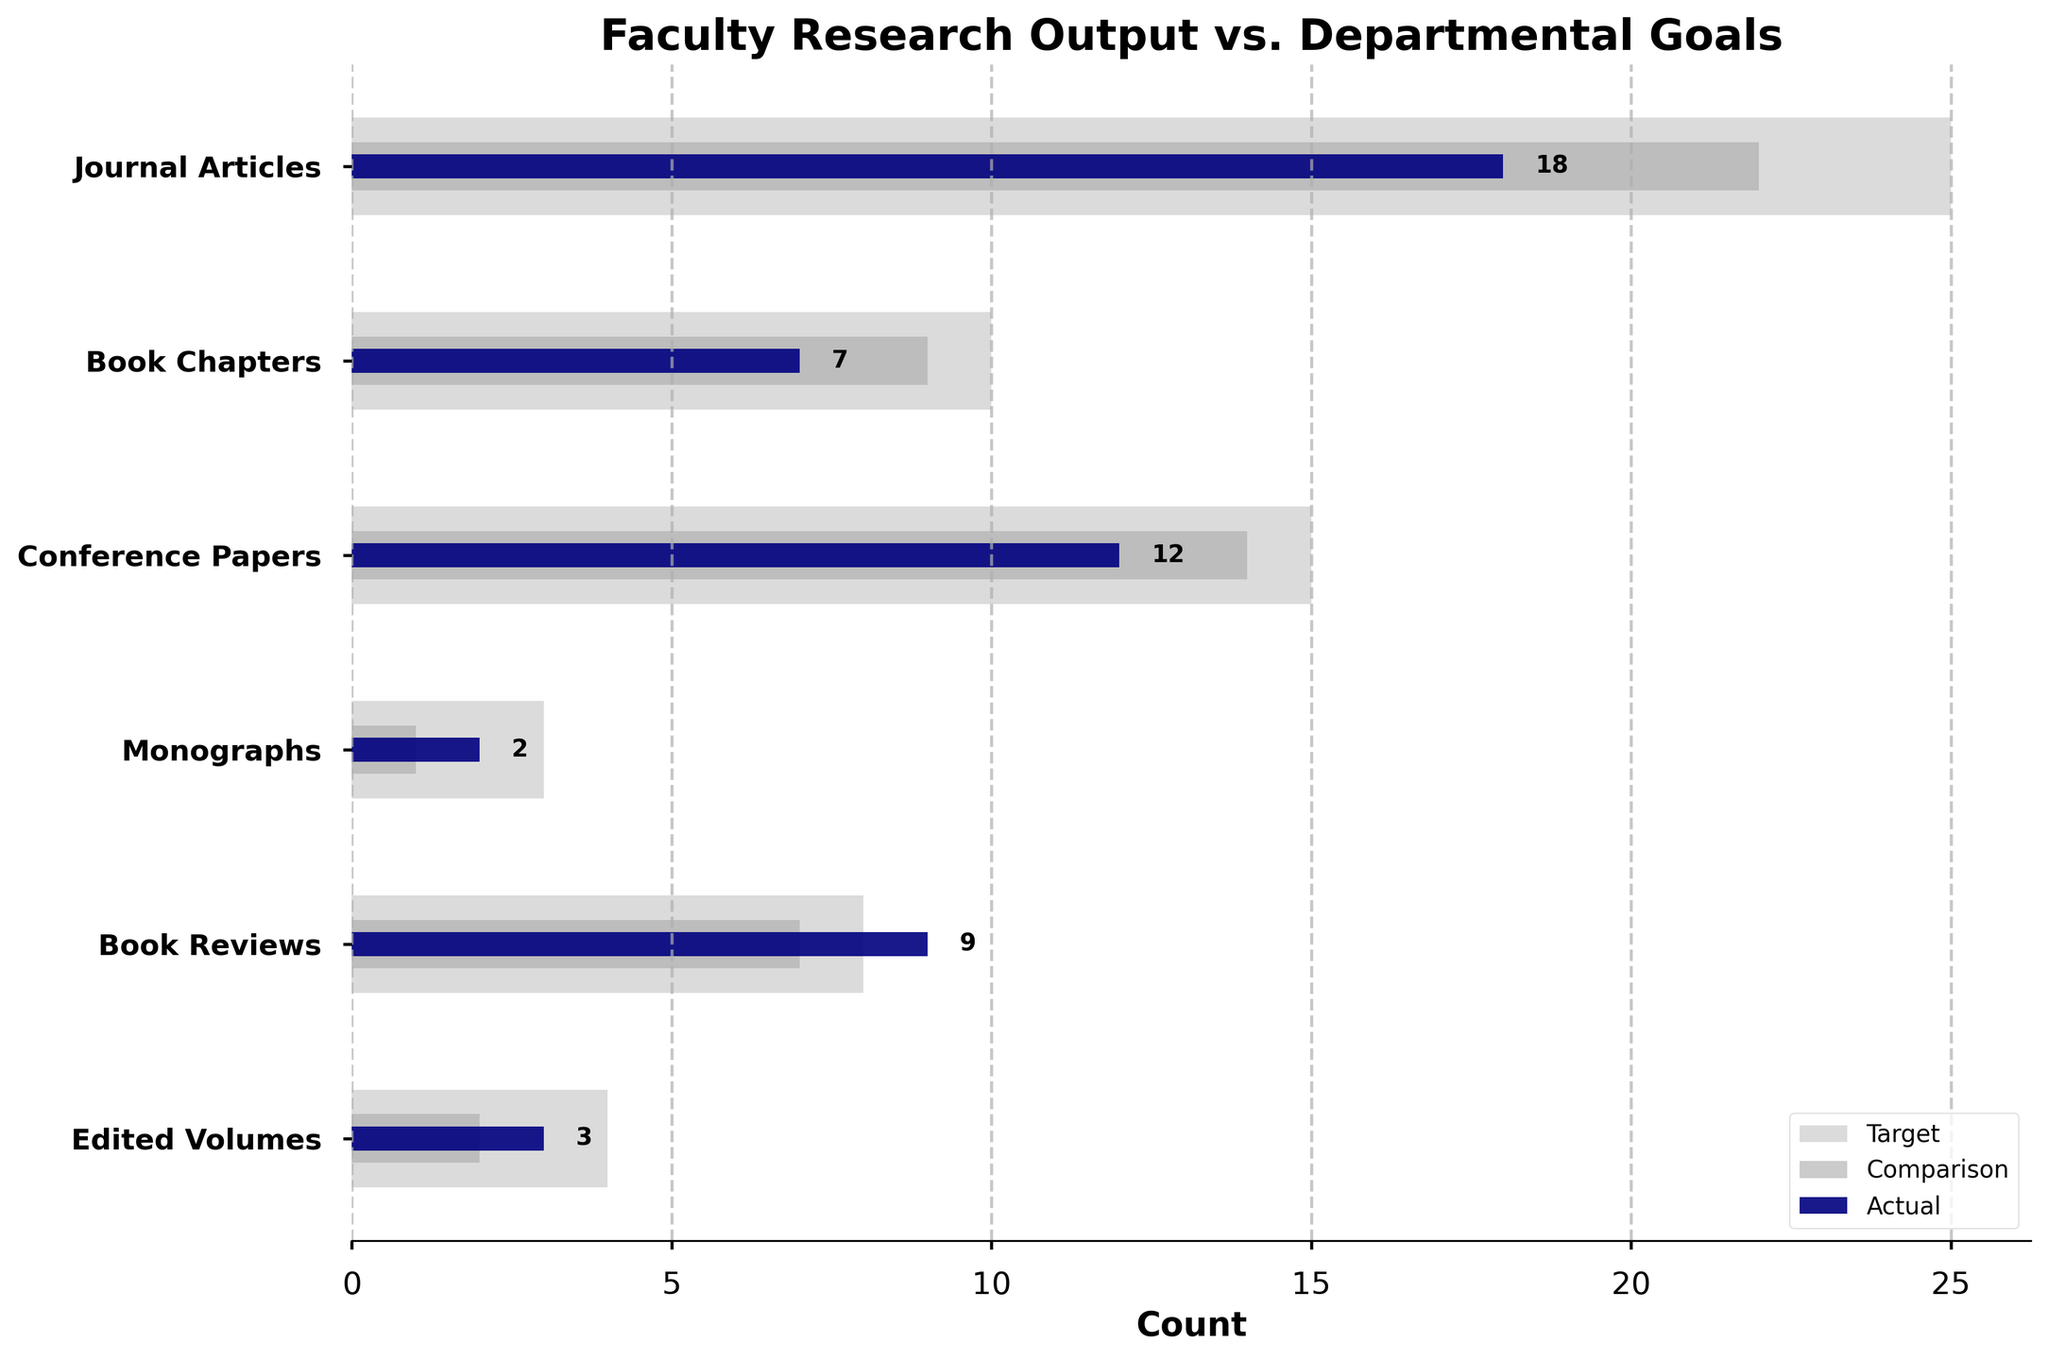What is the title of the chart? The title is displayed prominently at the top of the figure.
Answer: Faculty Research Output vs. Departmental Goals Which category has the highest actual research output? Look for the longest navy bar in the chart and read the associated category.
Answer: Journal Articles What is the actual count of Monographs? Find the position of "Monographs" on the y-axis and check the corresponding navy bar for its numerical value.
Answer: 2 In how many publication types did the faculty meet or exceed their comparison target? Compare the navy bar (Actual) with the dark grey bar (Comparison) in each category and count those where the navy bar is longer or equal.
Answer: 4 Which category shows the closest actual research output to its departmental goal? Calculate the difference between the navy bar (Actual) and the light grey bar (Target) for each category and find the smallest difference.
Answer: Book Reviews In which category is the gap between the actual output and the departmental goal the largest? Identify where the difference between the navy bar (Actual) and the light grey bar (Target) is the widest.
Answer: Journal Articles What is the total actual research output summed across all categories? Add up the values of the navy bars for each category: 18 + 7 + 12 + 2 + 9 + 3.
Answer: 51 How many categories have a lower actual output than their comparison target? Compare the length of the navy bars (Actual) with the dark grey bars (Comparison) and count those where the navy bars are shorter.
Answer: 2 By how many units does the actual output for Book Chapters fall short of the departmental goal? Subtract the navy bar value (Actual) from the light grey bar value (Target) for Book Chapters: 10 - 7.
Answer: 3 Which category has the smallest difference between the comparison and the actual output? Calculate the differences between the navy bars (Actual) and the dark grey bars (Comparison) for each category, and find the smallest difference.
Answer: Book Reviews 